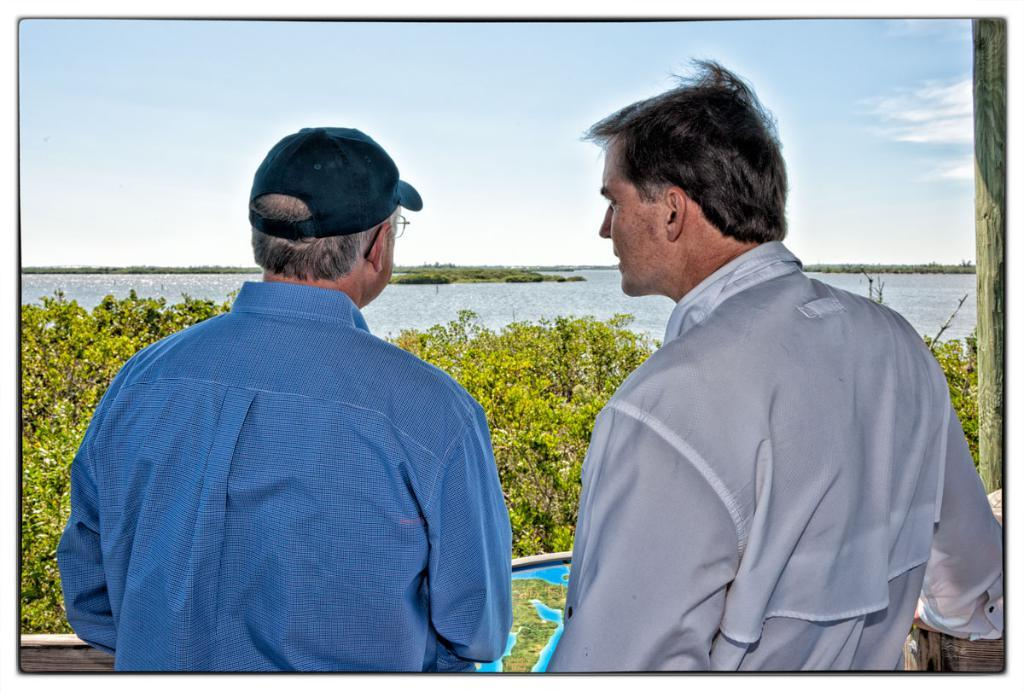How many people are in the image? There are two old men in the image. Where are the old men standing? The old men are standing in a verandah. What can be seen in the background of the image? There is a sea visible in the image, and it is in front of the old men. What is visible above the sea and the old men? The sky is visible in the image, and clouds are present in the sky. What are the old men doing to wash their clothes in the image? There is no indication in the image that the old men are washing their clothes or performing any such activity. 